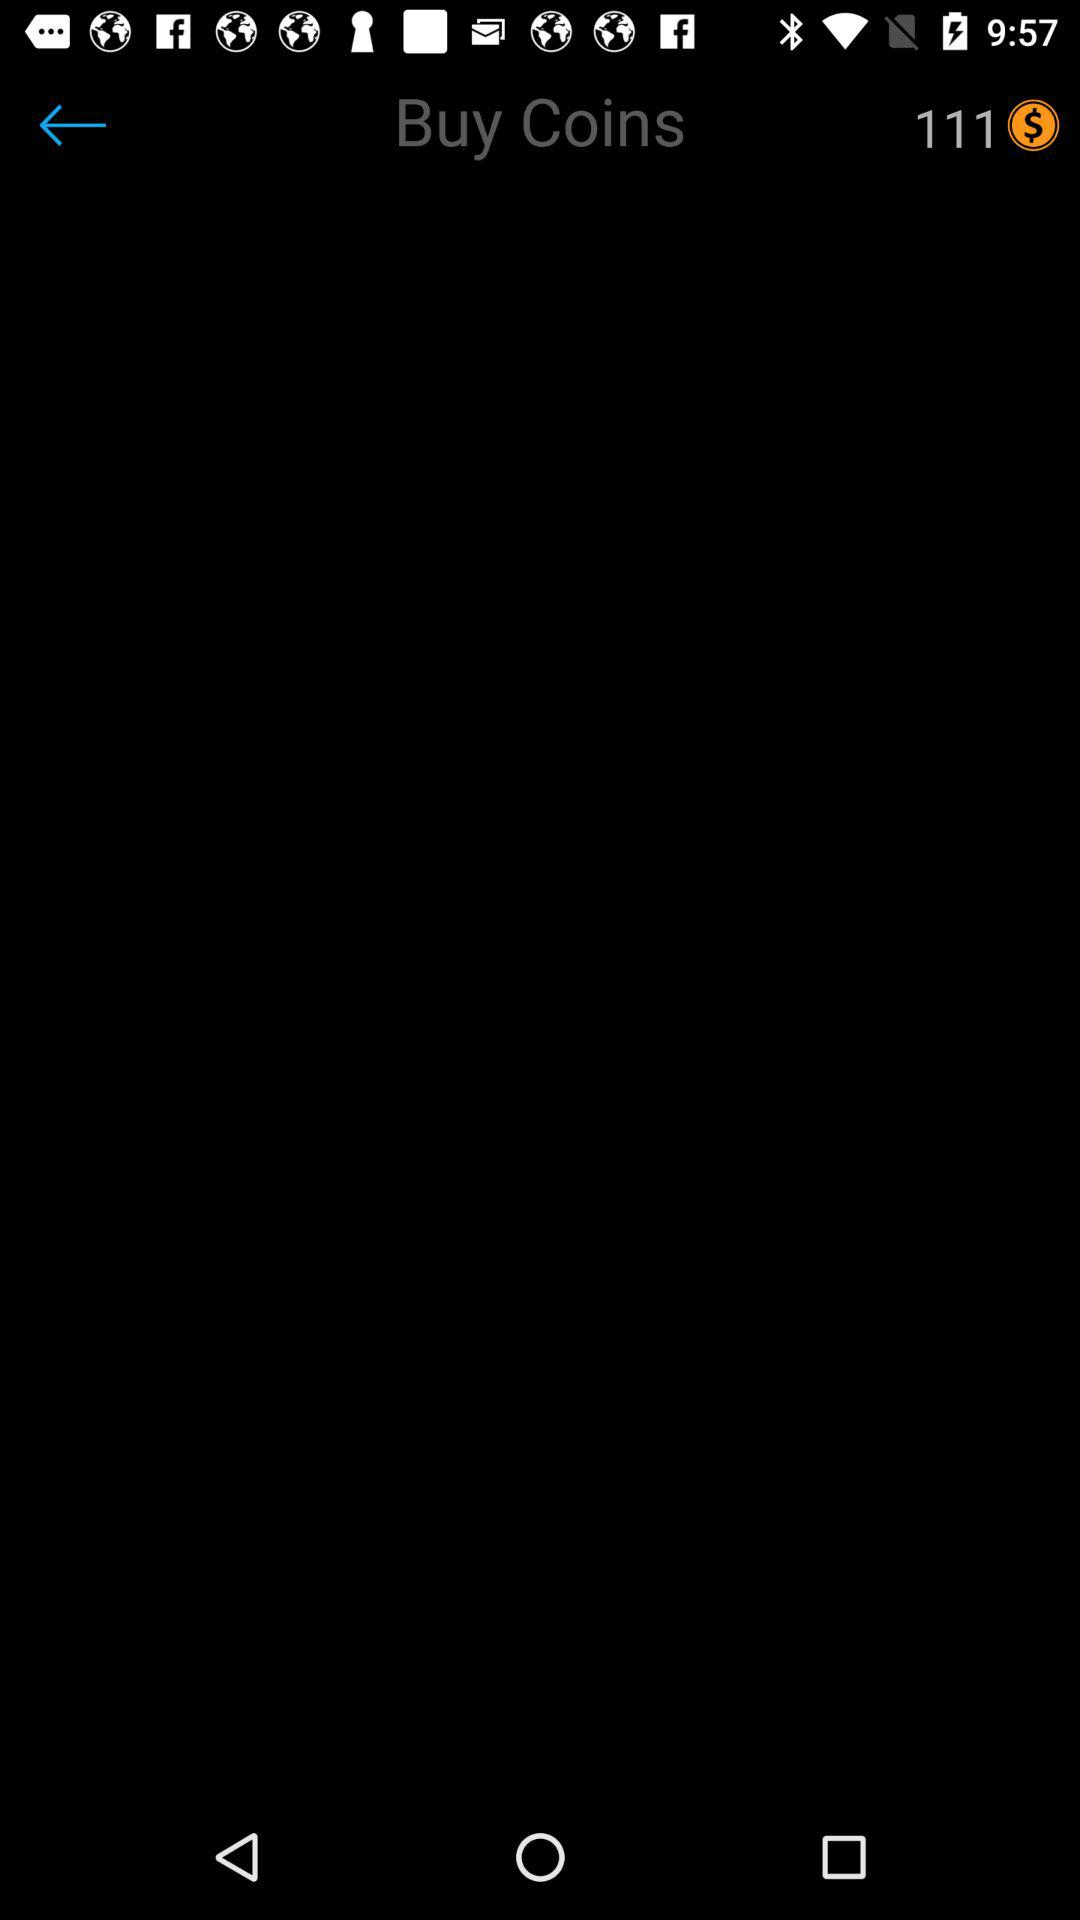How many coins are there in total? There are 111 coins in total. 